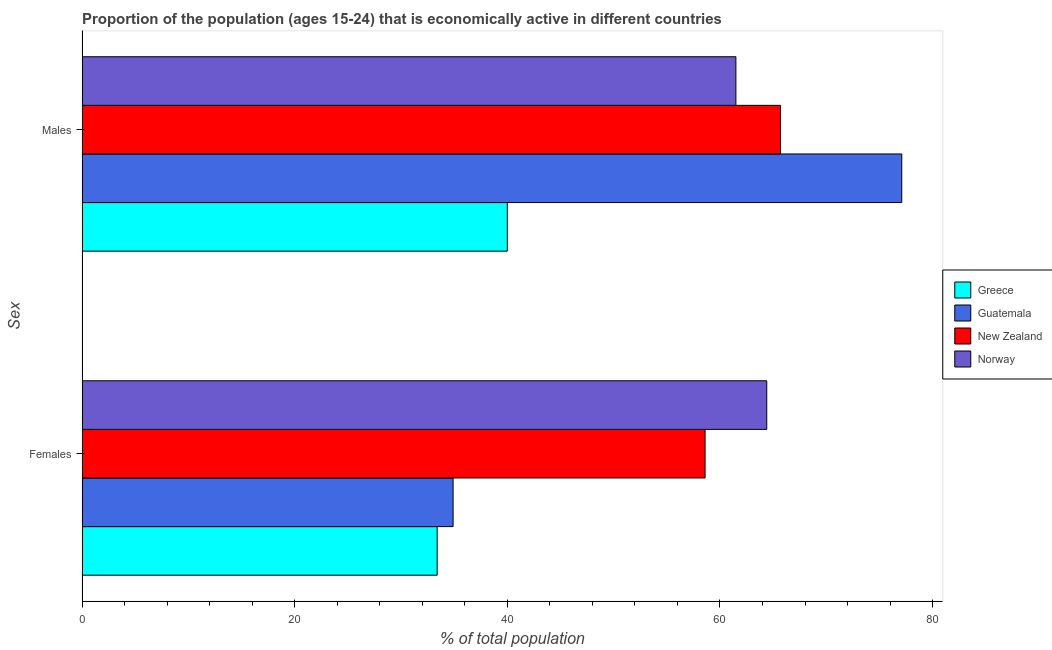How many groups of bars are there?
Offer a terse response. 2. Are the number of bars per tick equal to the number of legend labels?
Provide a succinct answer. Yes. Are the number of bars on each tick of the Y-axis equal?
Offer a terse response. Yes. How many bars are there on the 2nd tick from the top?
Offer a terse response. 4. How many bars are there on the 2nd tick from the bottom?
Offer a terse response. 4. What is the label of the 2nd group of bars from the top?
Give a very brief answer. Females. What is the percentage of economically active female population in Norway?
Keep it short and to the point. 64.4. Across all countries, what is the maximum percentage of economically active female population?
Provide a short and direct response. 64.4. Across all countries, what is the minimum percentage of economically active female population?
Give a very brief answer. 33.4. In which country was the percentage of economically active male population maximum?
Offer a very short reply. Guatemala. In which country was the percentage of economically active female population minimum?
Provide a short and direct response. Greece. What is the total percentage of economically active male population in the graph?
Make the answer very short. 244.3. What is the difference between the percentage of economically active female population in New Zealand and that in Guatemala?
Keep it short and to the point. 23.7. What is the difference between the percentage of economically active male population in Greece and the percentage of economically active female population in New Zealand?
Offer a terse response. -18.6. What is the average percentage of economically active female population per country?
Keep it short and to the point. 47.83. What is the difference between the percentage of economically active male population and percentage of economically active female population in Norway?
Make the answer very short. -2.9. What is the ratio of the percentage of economically active male population in Norway to that in Greece?
Your answer should be very brief. 1.54. Is the percentage of economically active female population in Guatemala less than that in Greece?
Keep it short and to the point. No. In how many countries, is the percentage of economically active male population greater than the average percentage of economically active male population taken over all countries?
Make the answer very short. 3. What does the 3rd bar from the top in Males represents?
Keep it short and to the point. Guatemala. What does the 1st bar from the bottom in Males represents?
Provide a short and direct response. Greece. Are all the bars in the graph horizontal?
Ensure brevity in your answer.  Yes. Does the graph contain grids?
Provide a short and direct response. No. Where does the legend appear in the graph?
Ensure brevity in your answer.  Center right. How many legend labels are there?
Provide a succinct answer. 4. What is the title of the graph?
Provide a short and direct response. Proportion of the population (ages 15-24) that is economically active in different countries. What is the label or title of the X-axis?
Your answer should be very brief. % of total population. What is the label or title of the Y-axis?
Provide a short and direct response. Sex. What is the % of total population of Greece in Females?
Make the answer very short. 33.4. What is the % of total population of Guatemala in Females?
Provide a short and direct response. 34.9. What is the % of total population in New Zealand in Females?
Your answer should be compact. 58.6. What is the % of total population in Norway in Females?
Keep it short and to the point. 64.4. What is the % of total population of Greece in Males?
Make the answer very short. 40. What is the % of total population in Guatemala in Males?
Your answer should be very brief. 77.1. What is the % of total population in New Zealand in Males?
Provide a short and direct response. 65.7. What is the % of total population in Norway in Males?
Make the answer very short. 61.5. Across all Sex, what is the maximum % of total population in Greece?
Make the answer very short. 40. Across all Sex, what is the maximum % of total population in Guatemala?
Offer a terse response. 77.1. Across all Sex, what is the maximum % of total population in New Zealand?
Give a very brief answer. 65.7. Across all Sex, what is the maximum % of total population in Norway?
Your answer should be compact. 64.4. Across all Sex, what is the minimum % of total population in Greece?
Provide a succinct answer. 33.4. Across all Sex, what is the minimum % of total population in Guatemala?
Keep it short and to the point. 34.9. Across all Sex, what is the minimum % of total population in New Zealand?
Provide a short and direct response. 58.6. Across all Sex, what is the minimum % of total population of Norway?
Offer a terse response. 61.5. What is the total % of total population in Greece in the graph?
Your answer should be compact. 73.4. What is the total % of total population in Guatemala in the graph?
Make the answer very short. 112. What is the total % of total population of New Zealand in the graph?
Provide a succinct answer. 124.3. What is the total % of total population in Norway in the graph?
Your answer should be very brief. 125.9. What is the difference between the % of total population in Guatemala in Females and that in Males?
Provide a succinct answer. -42.2. What is the difference between the % of total population of New Zealand in Females and that in Males?
Provide a short and direct response. -7.1. What is the difference between the % of total population in Norway in Females and that in Males?
Your response must be concise. 2.9. What is the difference between the % of total population of Greece in Females and the % of total population of Guatemala in Males?
Offer a very short reply. -43.7. What is the difference between the % of total population in Greece in Females and the % of total population in New Zealand in Males?
Offer a very short reply. -32.3. What is the difference between the % of total population of Greece in Females and the % of total population of Norway in Males?
Offer a terse response. -28.1. What is the difference between the % of total population in Guatemala in Females and the % of total population in New Zealand in Males?
Provide a short and direct response. -30.8. What is the difference between the % of total population of Guatemala in Females and the % of total population of Norway in Males?
Your answer should be very brief. -26.6. What is the average % of total population in Greece per Sex?
Make the answer very short. 36.7. What is the average % of total population of New Zealand per Sex?
Provide a succinct answer. 62.15. What is the average % of total population in Norway per Sex?
Your answer should be very brief. 62.95. What is the difference between the % of total population in Greece and % of total population in Guatemala in Females?
Make the answer very short. -1.5. What is the difference between the % of total population of Greece and % of total population of New Zealand in Females?
Offer a very short reply. -25.2. What is the difference between the % of total population in Greece and % of total population in Norway in Females?
Your response must be concise. -31. What is the difference between the % of total population in Guatemala and % of total population in New Zealand in Females?
Keep it short and to the point. -23.7. What is the difference between the % of total population of Guatemala and % of total population of Norway in Females?
Ensure brevity in your answer.  -29.5. What is the difference between the % of total population in Greece and % of total population in Guatemala in Males?
Give a very brief answer. -37.1. What is the difference between the % of total population in Greece and % of total population in New Zealand in Males?
Provide a succinct answer. -25.7. What is the difference between the % of total population in Greece and % of total population in Norway in Males?
Provide a short and direct response. -21.5. What is the difference between the % of total population in Guatemala and % of total population in Norway in Males?
Your answer should be very brief. 15.6. What is the ratio of the % of total population of Greece in Females to that in Males?
Keep it short and to the point. 0.83. What is the ratio of the % of total population of Guatemala in Females to that in Males?
Offer a terse response. 0.45. What is the ratio of the % of total population in New Zealand in Females to that in Males?
Your response must be concise. 0.89. What is the ratio of the % of total population of Norway in Females to that in Males?
Your response must be concise. 1.05. What is the difference between the highest and the second highest % of total population in Greece?
Make the answer very short. 6.6. What is the difference between the highest and the second highest % of total population in Guatemala?
Your answer should be compact. 42.2. What is the difference between the highest and the second highest % of total population in New Zealand?
Your answer should be very brief. 7.1. What is the difference between the highest and the second highest % of total population in Norway?
Ensure brevity in your answer.  2.9. What is the difference between the highest and the lowest % of total population in Guatemala?
Keep it short and to the point. 42.2. What is the difference between the highest and the lowest % of total population in New Zealand?
Your answer should be very brief. 7.1. What is the difference between the highest and the lowest % of total population of Norway?
Offer a very short reply. 2.9. 